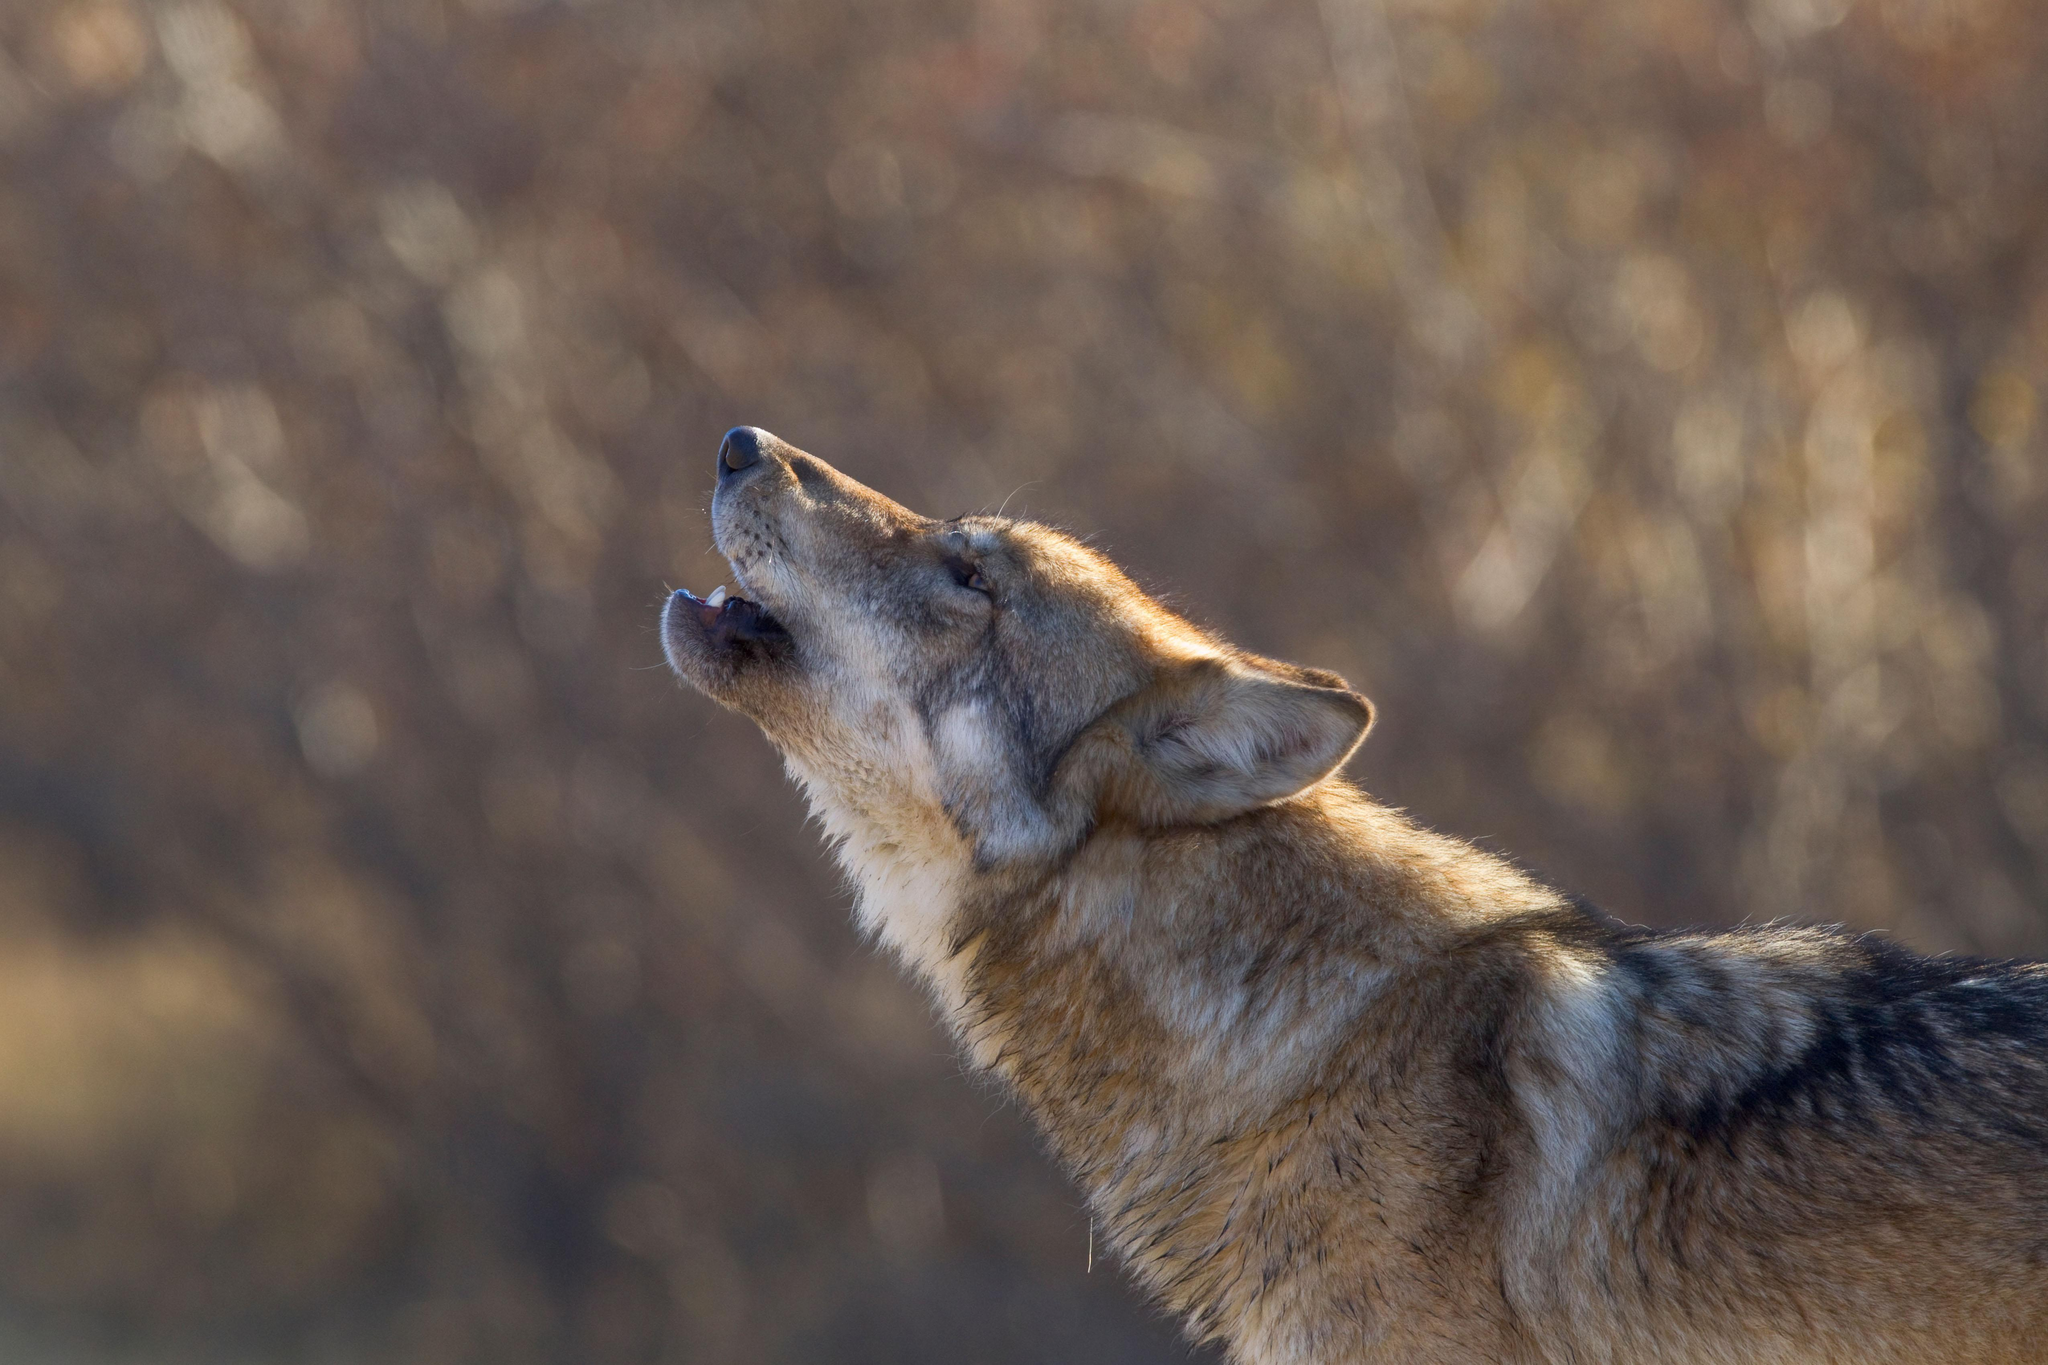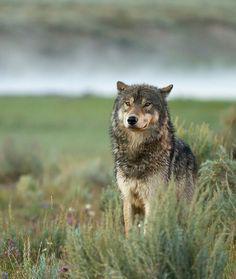The first image is the image on the left, the second image is the image on the right. Assess this claim about the two images: "There are only two wolves and neither of them are howling.". Correct or not? Answer yes or no. No. 